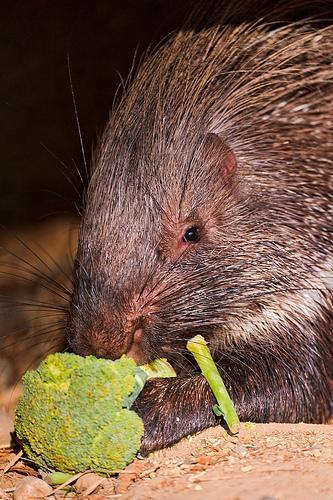How many animals are shown?
Give a very brief answer. 1. 